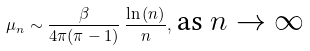Convert formula to latex. <formula><loc_0><loc_0><loc_500><loc_500>\mu _ { n } \sim \frac { \beta } { 4 \pi ( \pi - 1 ) } \, \frac { \ln { ( n ) } } { n } , \, \text {as $n \to \infty$}</formula> 